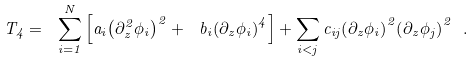<formula> <loc_0><loc_0><loc_500><loc_500>T _ { 4 } = \ \sum _ { i = 1 } ^ { N } \left [ a _ { i } { \left ( \partial ^ { 2 } _ { z } \phi _ { i } \right ) } ^ { 2 } + \ b _ { i } { \left ( \partial _ { z } \phi _ { i } \right ) } ^ { 4 } \right ] + \sum _ { i < j } c _ { i j } { \left ( \partial _ { z } \phi _ { i } \right ) } ^ { 2 } { \left ( \partial _ { z } \phi _ { j } \right ) } ^ { 2 } \ .</formula> 